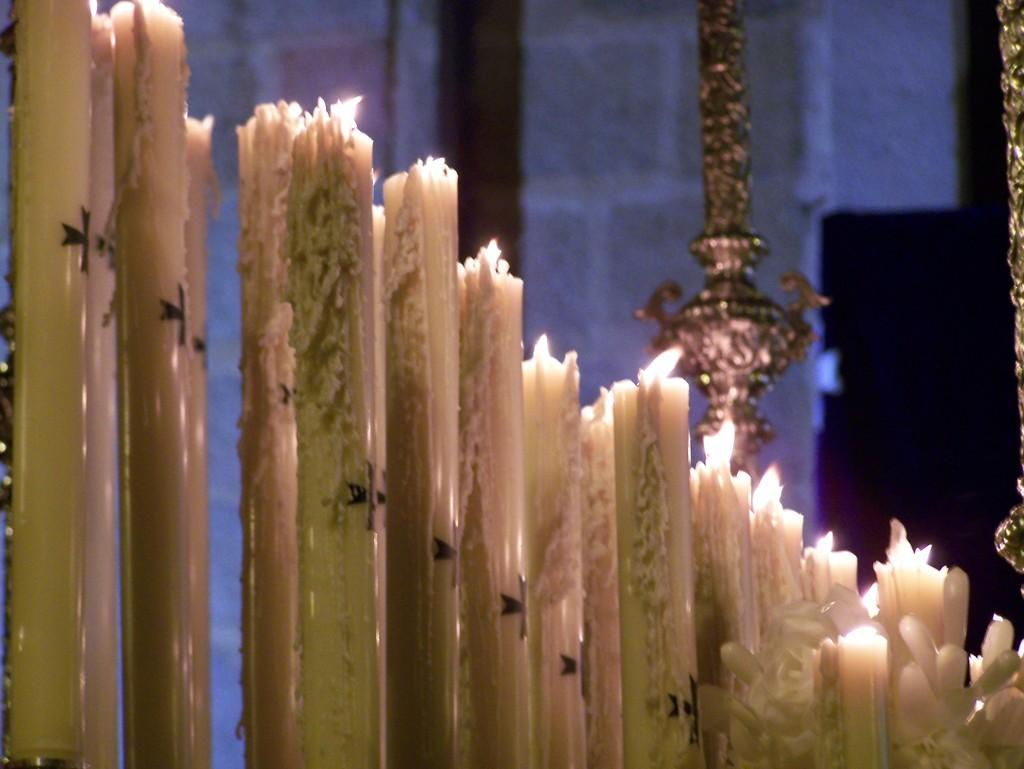What is the primary feature of the image? There are many candles with flames in the image. Are there any other objects or elements present in the image? Yes, there are flowers in the right bottom corner of the image, and a metal object and a wall in the background. What type of trade is being conducted in the image? There is no indication of any trade being conducted in the image; it primarily features candles with flames and flowers. Can you see a cat in the image? No, there is no cat present in the image. 